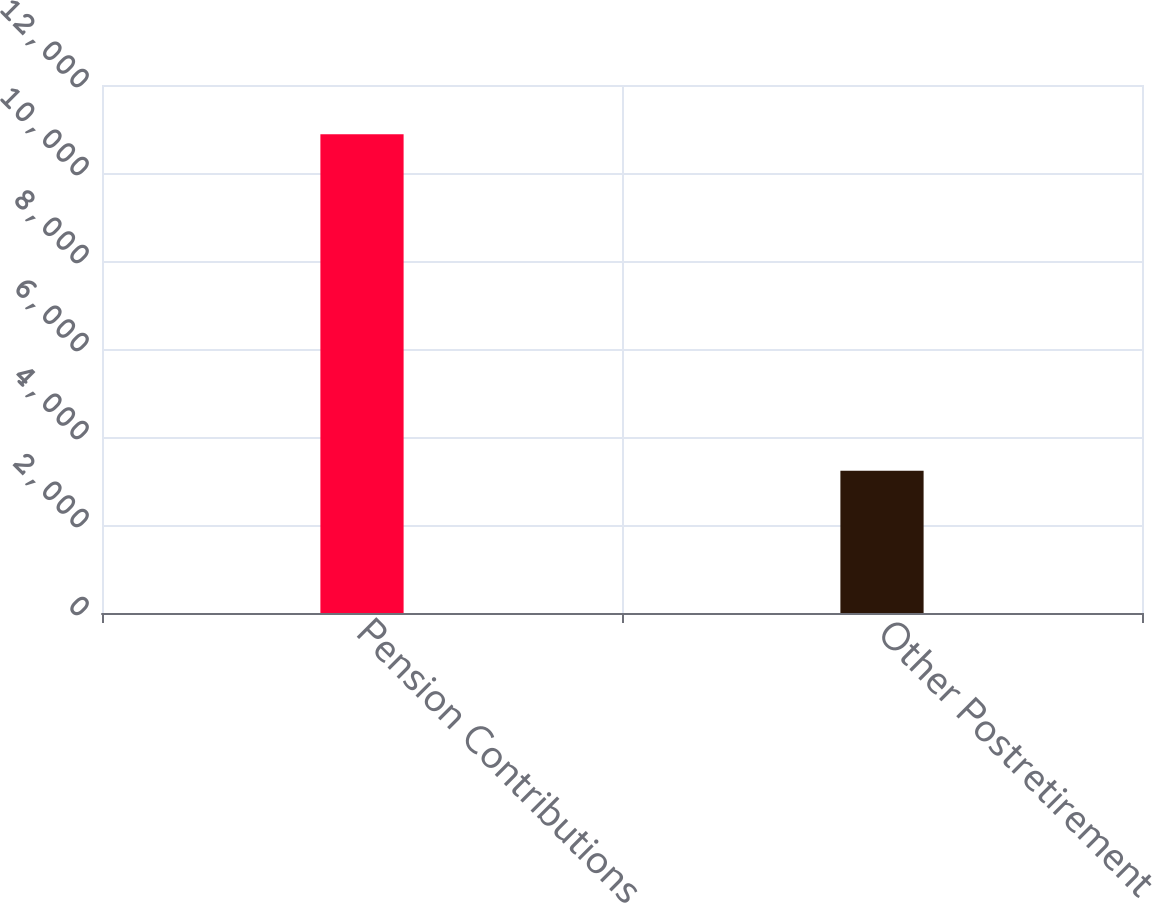<chart> <loc_0><loc_0><loc_500><loc_500><bar_chart><fcel>Pension Contributions<fcel>Other Postretirement<nl><fcel>10883<fcel>3231<nl></chart> 